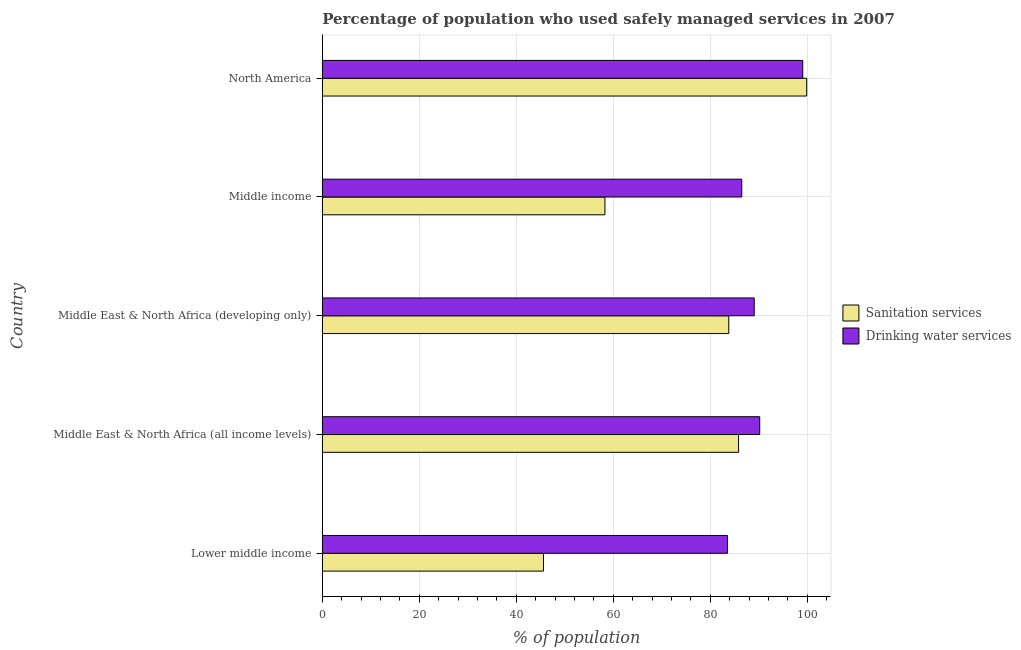Are the number of bars on each tick of the Y-axis equal?
Provide a short and direct response. Yes. How many bars are there on the 4th tick from the bottom?
Make the answer very short. 2. What is the label of the 4th group of bars from the top?
Ensure brevity in your answer.  Middle East & North Africa (all income levels). What is the percentage of population who used sanitation services in Middle East & North Africa (all income levels)?
Provide a succinct answer. 85.84. Across all countries, what is the maximum percentage of population who used drinking water services?
Keep it short and to the point. 99.08. Across all countries, what is the minimum percentage of population who used drinking water services?
Give a very brief answer. 83.55. In which country was the percentage of population who used sanitation services minimum?
Provide a succinct answer. Lower middle income. What is the total percentage of population who used sanitation services in the graph?
Your answer should be compact. 373.45. What is the difference between the percentage of population who used drinking water services in Middle East & North Africa (all income levels) and that in Middle income?
Your answer should be very brief. 3.7. What is the difference between the percentage of population who used sanitation services in North America and the percentage of population who used drinking water services in Middle East & North Africa (all income levels)?
Your response must be concise. 9.69. What is the average percentage of population who used drinking water services per country?
Keep it short and to the point. 89.68. What is the difference between the percentage of population who used drinking water services and percentage of population who used sanitation services in Middle East & North Africa (all income levels)?
Provide a succinct answer. 4.36. In how many countries, is the percentage of population who used drinking water services greater than 40 %?
Your response must be concise. 5. What is the ratio of the percentage of population who used drinking water services in Middle East & North Africa (all income levels) to that in Middle income?
Offer a very short reply. 1.04. Is the percentage of population who used drinking water services in Lower middle income less than that in Middle East & North Africa (all income levels)?
Provide a short and direct response. Yes. Is the difference between the percentage of population who used sanitation services in Middle income and North America greater than the difference between the percentage of population who used drinking water services in Middle income and North America?
Provide a succinct answer. No. What is the difference between the highest and the second highest percentage of population who used sanitation services?
Offer a very short reply. 14.05. What is the difference between the highest and the lowest percentage of population who used drinking water services?
Keep it short and to the point. 15.53. What does the 2nd bar from the top in Middle East & North Africa (developing only) represents?
Make the answer very short. Sanitation services. What does the 2nd bar from the bottom in Lower middle income represents?
Make the answer very short. Drinking water services. Are all the bars in the graph horizontal?
Your answer should be compact. Yes. How many countries are there in the graph?
Make the answer very short. 5. What is the difference between two consecutive major ticks on the X-axis?
Your answer should be very brief. 20. Does the graph contain any zero values?
Ensure brevity in your answer.  No. How many legend labels are there?
Give a very brief answer. 2. How are the legend labels stacked?
Ensure brevity in your answer.  Vertical. What is the title of the graph?
Your response must be concise. Percentage of population who used safely managed services in 2007. Does "Commercial service exports" appear as one of the legend labels in the graph?
Your response must be concise. No. What is the label or title of the X-axis?
Keep it short and to the point. % of population. What is the % of population in Sanitation services in Lower middle income?
Make the answer very short. 45.61. What is the % of population of Drinking water services in Lower middle income?
Make the answer very short. 83.55. What is the % of population of Sanitation services in Middle East & North Africa (all income levels)?
Provide a succinct answer. 85.84. What is the % of population in Drinking water services in Middle East & North Africa (all income levels)?
Make the answer very short. 90.21. What is the % of population of Sanitation services in Middle East & North Africa (developing only)?
Provide a short and direct response. 83.82. What is the % of population in Drinking water services in Middle East & North Africa (developing only)?
Keep it short and to the point. 89.07. What is the % of population in Sanitation services in Middle income?
Ensure brevity in your answer.  58.28. What is the % of population of Drinking water services in Middle income?
Keep it short and to the point. 86.5. What is the % of population of Sanitation services in North America?
Make the answer very short. 99.89. What is the % of population in Drinking water services in North America?
Provide a short and direct response. 99.08. Across all countries, what is the maximum % of population in Sanitation services?
Give a very brief answer. 99.89. Across all countries, what is the maximum % of population in Drinking water services?
Your answer should be compact. 99.08. Across all countries, what is the minimum % of population in Sanitation services?
Make the answer very short. 45.61. Across all countries, what is the minimum % of population of Drinking water services?
Ensure brevity in your answer.  83.55. What is the total % of population of Sanitation services in the graph?
Ensure brevity in your answer.  373.45. What is the total % of population of Drinking water services in the graph?
Offer a terse response. 448.4. What is the difference between the % of population in Sanitation services in Lower middle income and that in Middle East & North Africa (all income levels)?
Offer a very short reply. -40.23. What is the difference between the % of population of Drinking water services in Lower middle income and that in Middle East & North Africa (all income levels)?
Your answer should be very brief. -6.66. What is the difference between the % of population of Sanitation services in Lower middle income and that in Middle East & North Africa (developing only)?
Ensure brevity in your answer.  -38.21. What is the difference between the % of population in Drinking water services in Lower middle income and that in Middle East & North Africa (developing only)?
Keep it short and to the point. -5.52. What is the difference between the % of population in Sanitation services in Lower middle income and that in Middle income?
Offer a very short reply. -12.67. What is the difference between the % of population of Drinking water services in Lower middle income and that in Middle income?
Your response must be concise. -2.95. What is the difference between the % of population in Sanitation services in Lower middle income and that in North America?
Your response must be concise. -54.28. What is the difference between the % of population in Drinking water services in Lower middle income and that in North America?
Offer a terse response. -15.53. What is the difference between the % of population in Sanitation services in Middle East & North Africa (all income levels) and that in Middle East & North Africa (developing only)?
Your answer should be compact. 2.02. What is the difference between the % of population in Drinking water services in Middle East & North Africa (all income levels) and that in Middle East & North Africa (developing only)?
Keep it short and to the point. 1.13. What is the difference between the % of population of Sanitation services in Middle East & North Africa (all income levels) and that in Middle income?
Provide a short and direct response. 27.56. What is the difference between the % of population of Drinking water services in Middle East & North Africa (all income levels) and that in Middle income?
Provide a succinct answer. 3.7. What is the difference between the % of population in Sanitation services in Middle East & North Africa (all income levels) and that in North America?
Make the answer very short. -14.05. What is the difference between the % of population in Drinking water services in Middle East & North Africa (all income levels) and that in North America?
Give a very brief answer. -8.87. What is the difference between the % of population in Sanitation services in Middle East & North Africa (developing only) and that in Middle income?
Your response must be concise. 25.54. What is the difference between the % of population of Drinking water services in Middle East & North Africa (developing only) and that in Middle income?
Provide a short and direct response. 2.57. What is the difference between the % of population of Sanitation services in Middle East & North Africa (developing only) and that in North America?
Offer a very short reply. -16.07. What is the difference between the % of population of Drinking water services in Middle East & North Africa (developing only) and that in North America?
Provide a succinct answer. -10.01. What is the difference between the % of population in Sanitation services in Middle income and that in North America?
Your answer should be very brief. -41.61. What is the difference between the % of population in Drinking water services in Middle income and that in North America?
Give a very brief answer. -12.58. What is the difference between the % of population of Sanitation services in Lower middle income and the % of population of Drinking water services in Middle East & North Africa (all income levels)?
Offer a terse response. -44.6. What is the difference between the % of population of Sanitation services in Lower middle income and the % of population of Drinking water services in Middle East & North Africa (developing only)?
Provide a short and direct response. -43.46. What is the difference between the % of population of Sanitation services in Lower middle income and the % of population of Drinking water services in Middle income?
Your answer should be very brief. -40.89. What is the difference between the % of population of Sanitation services in Lower middle income and the % of population of Drinking water services in North America?
Keep it short and to the point. -53.47. What is the difference between the % of population in Sanitation services in Middle East & North Africa (all income levels) and the % of population in Drinking water services in Middle East & North Africa (developing only)?
Your response must be concise. -3.23. What is the difference between the % of population in Sanitation services in Middle East & North Africa (all income levels) and the % of population in Drinking water services in Middle income?
Provide a short and direct response. -0.66. What is the difference between the % of population of Sanitation services in Middle East & North Africa (all income levels) and the % of population of Drinking water services in North America?
Your answer should be very brief. -13.24. What is the difference between the % of population of Sanitation services in Middle East & North Africa (developing only) and the % of population of Drinking water services in Middle income?
Your response must be concise. -2.68. What is the difference between the % of population of Sanitation services in Middle East & North Africa (developing only) and the % of population of Drinking water services in North America?
Your answer should be very brief. -15.26. What is the difference between the % of population of Sanitation services in Middle income and the % of population of Drinking water services in North America?
Your response must be concise. -40.79. What is the average % of population of Sanitation services per country?
Your response must be concise. 74.69. What is the average % of population of Drinking water services per country?
Your answer should be very brief. 89.68. What is the difference between the % of population of Sanitation services and % of population of Drinking water services in Lower middle income?
Give a very brief answer. -37.94. What is the difference between the % of population of Sanitation services and % of population of Drinking water services in Middle East & North Africa (all income levels)?
Keep it short and to the point. -4.36. What is the difference between the % of population of Sanitation services and % of population of Drinking water services in Middle East & North Africa (developing only)?
Provide a succinct answer. -5.25. What is the difference between the % of population in Sanitation services and % of population in Drinking water services in Middle income?
Ensure brevity in your answer.  -28.22. What is the difference between the % of population in Sanitation services and % of population in Drinking water services in North America?
Give a very brief answer. 0.81. What is the ratio of the % of population in Sanitation services in Lower middle income to that in Middle East & North Africa (all income levels)?
Your response must be concise. 0.53. What is the ratio of the % of population of Drinking water services in Lower middle income to that in Middle East & North Africa (all income levels)?
Ensure brevity in your answer.  0.93. What is the ratio of the % of population of Sanitation services in Lower middle income to that in Middle East & North Africa (developing only)?
Offer a very short reply. 0.54. What is the ratio of the % of population of Drinking water services in Lower middle income to that in Middle East & North Africa (developing only)?
Make the answer very short. 0.94. What is the ratio of the % of population of Sanitation services in Lower middle income to that in Middle income?
Provide a succinct answer. 0.78. What is the ratio of the % of population of Drinking water services in Lower middle income to that in Middle income?
Offer a terse response. 0.97. What is the ratio of the % of population of Sanitation services in Lower middle income to that in North America?
Your response must be concise. 0.46. What is the ratio of the % of population in Drinking water services in Lower middle income to that in North America?
Ensure brevity in your answer.  0.84. What is the ratio of the % of population in Sanitation services in Middle East & North Africa (all income levels) to that in Middle East & North Africa (developing only)?
Ensure brevity in your answer.  1.02. What is the ratio of the % of population of Drinking water services in Middle East & North Africa (all income levels) to that in Middle East & North Africa (developing only)?
Keep it short and to the point. 1.01. What is the ratio of the % of population of Sanitation services in Middle East & North Africa (all income levels) to that in Middle income?
Offer a very short reply. 1.47. What is the ratio of the % of population in Drinking water services in Middle East & North Africa (all income levels) to that in Middle income?
Offer a terse response. 1.04. What is the ratio of the % of population of Sanitation services in Middle East & North Africa (all income levels) to that in North America?
Give a very brief answer. 0.86. What is the ratio of the % of population in Drinking water services in Middle East & North Africa (all income levels) to that in North America?
Provide a succinct answer. 0.91. What is the ratio of the % of population of Sanitation services in Middle East & North Africa (developing only) to that in Middle income?
Make the answer very short. 1.44. What is the ratio of the % of population of Drinking water services in Middle East & North Africa (developing only) to that in Middle income?
Keep it short and to the point. 1.03. What is the ratio of the % of population in Sanitation services in Middle East & North Africa (developing only) to that in North America?
Ensure brevity in your answer.  0.84. What is the ratio of the % of population in Drinking water services in Middle East & North Africa (developing only) to that in North America?
Keep it short and to the point. 0.9. What is the ratio of the % of population in Sanitation services in Middle income to that in North America?
Offer a very short reply. 0.58. What is the ratio of the % of population in Drinking water services in Middle income to that in North America?
Ensure brevity in your answer.  0.87. What is the difference between the highest and the second highest % of population of Sanitation services?
Offer a terse response. 14.05. What is the difference between the highest and the second highest % of population of Drinking water services?
Provide a succinct answer. 8.87. What is the difference between the highest and the lowest % of population of Sanitation services?
Give a very brief answer. 54.28. What is the difference between the highest and the lowest % of population in Drinking water services?
Keep it short and to the point. 15.53. 